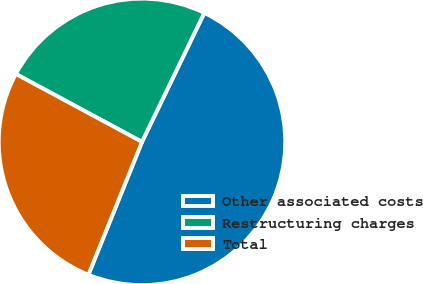Convert chart to OTSL. <chart><loc_0><loc_0><loc_500><loc_500><pie_chart><fcel>Other associated costs<fcel>Restructuring charges<fcel>Total<nl><fcel>48.94%<fcel>24.3%<fcel>26.76%<nl></chart> 